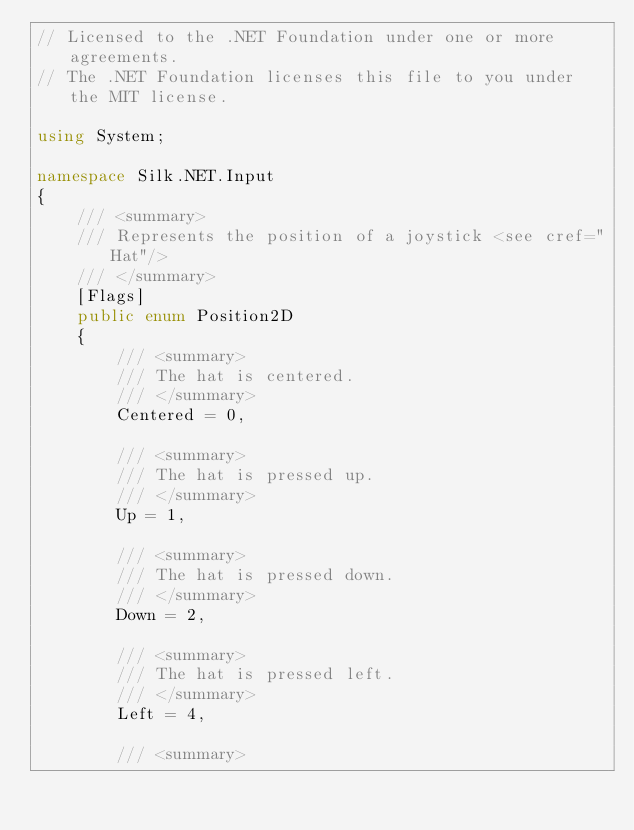<code> <loc_0><loc_0><loc_500><loc_500><_C#_>// Licensed to the .NET Foundation under one or more agreements.
// The .NET Foundation licenses this file to you under the MIT license.

using System;

namespace Silk.NET.Input
{
    /// <summary>
    /// Represents the position of a joystick <see cref="Hat"/>
    /// </summary>
    [Flags]
    public enum Position2D
    {
        /// <summary>
        /// The hat is centered.
        /// </summary>
        Centered = 0,

        /// <summary>
        /// The hat is pressed up.
        /// </summary>
        Up = 1,

        /// <summary>
        /// The hat is pressed down.
        /// </summary>
        Down = 2,

        /// <summary>
        /// The hat is pressed left.
        /// </summary>
        Left = 4,

        /// <summary></code> 